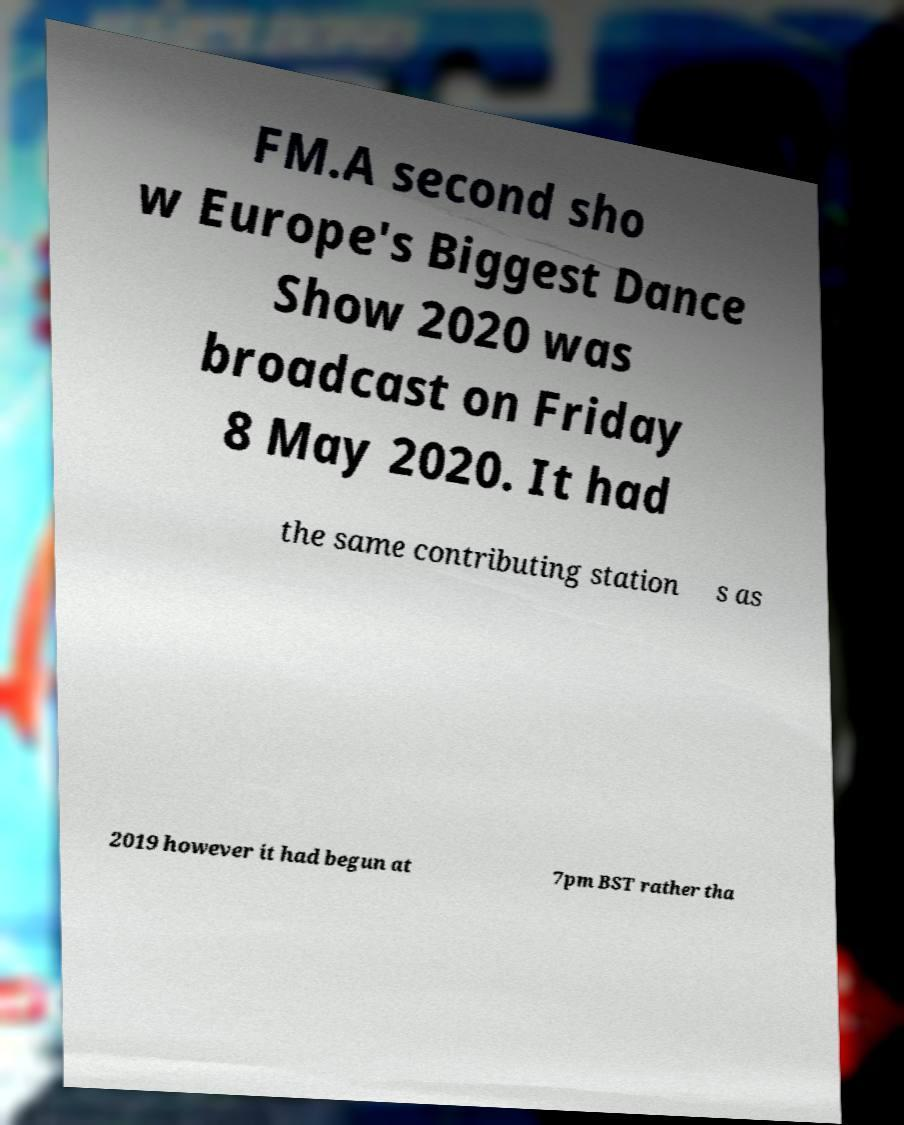What messages or text are displayed in this image? I need them in a readable, typed format. FM.A second sho w Europe's Biggest Dance Show 2020 was broadcast on Friday 8 May 2020. It had the same contributing station s as 2019 however it had begun at 7pm BST rather tha 